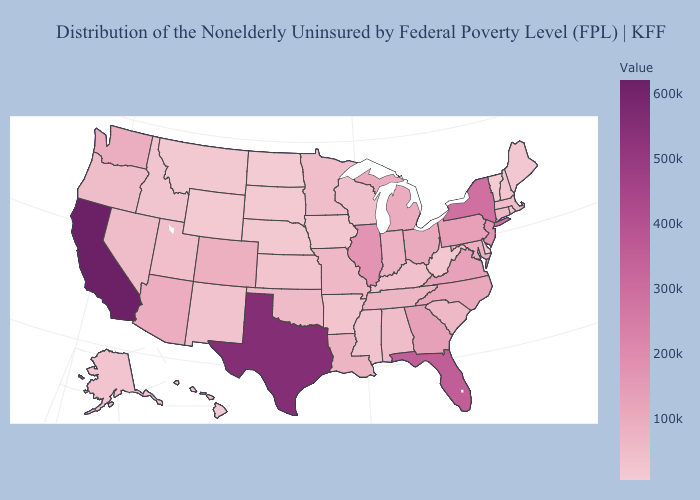Does North Carolina have a higher value than North Dakota?
Be succinct. Yes. Among the states that border Illinois , which have the highest value?
Quick response, please. Indiana. Is the legend a continuous bar?
Give a very brief answer. Yes. Does Colorado have the lowest value in the West?
Be succinct. No. 